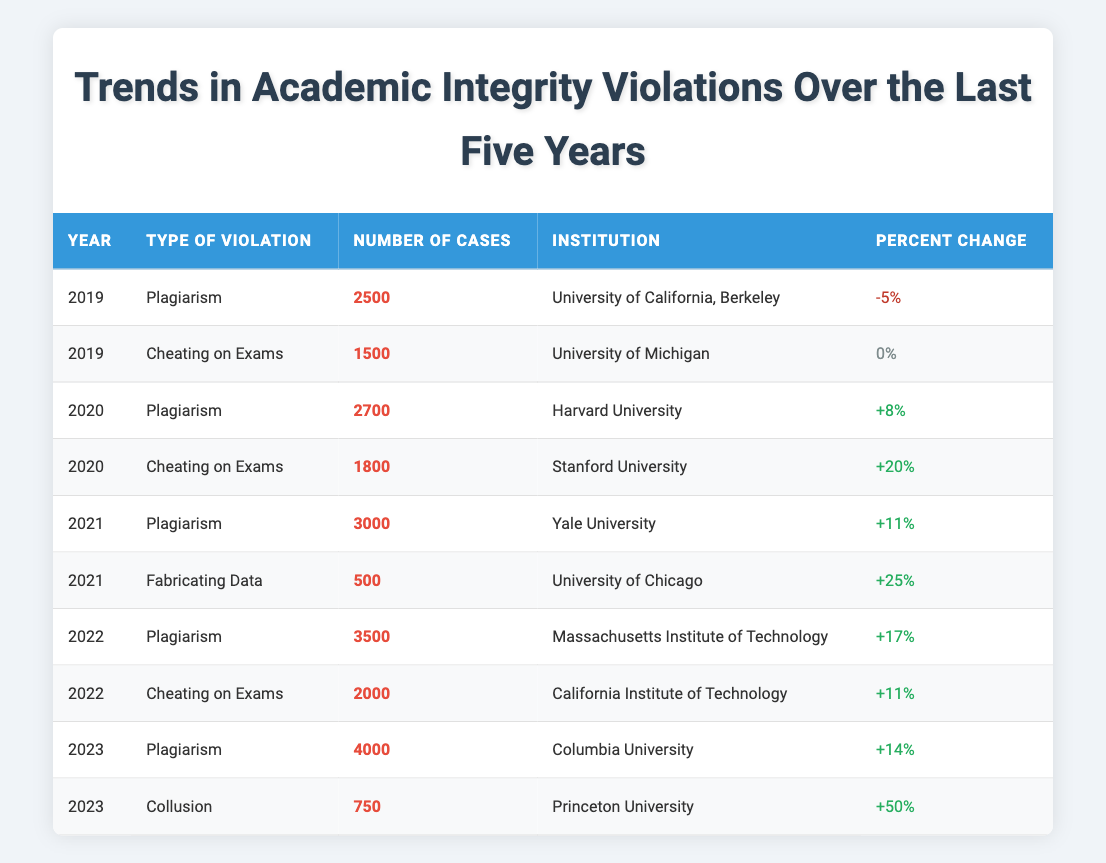What was the number of plagiarism cases in 2022? The table shows that there were 3500 plagiarism cases listed for the year 2022.
Answer: 3500 Which institution reported the highest number of cheating cases on exams in 2020? According to the table, Stanford University reported the highest number of cheating cases on exams in 2020, with 1800 cases.
Answer: Stanford University Calculate the total number of plagiarism cases reported from 2019 to 2023. To find the total, sum the number of plagiarism cases from each year: 2500 (2019) + 2700 (2020) + 3000 (2021) + 3500 (2022) + 4000 (2023) = 15700.
Answer: 15700 Is there a year where the percent change in cheating cases on exams was negative? When examining the percentages for cheating cases on exams, there is no entry with a negative percent change since all entries are either positive or zero.
Answer: No Which type of violation had the greatest percent change in 2023? The percent change for collusion in 2023 was +50%, which was the highest percent change among all violations that year.
Answer: Collusion Did the number of plagiarism cases increase every year from 2019 to 2023? By looking at the cases from 2019 (2500) to 2023 (4000), it can be seen that the number of plagiarism cases increased each year.
Answer: Yes What was the total number of academic integrity violations recorded in 2021? In 2021, there were 3000 cases of plagiarism and 500 cases of fabricating data. The total for that year is 3000 + 500 = 3500.
Answer: 3500 In which year was there no change in the number of cheating cases? The table indicates that in 2019, the number of cheating cases on exams reported by the University of Michigan had a percent change of 0%.
Answer: 2019 Which institution had the least number of data fabrications in 2021? The sole mention of fabricating data in 2021 was the University of Chicago, reporting 500 cases, which is the only data available for that type of violation that year.
Answer: University of Chicago What was the average number of cases of plagiarism over the years listed? To calculate the average for plagiarism: (2500 + 2700 + 3000 + 3500 + 4000) / 5 = 3140. The average number of plagiarism cases is therefore 3140.
Answer: 3140 